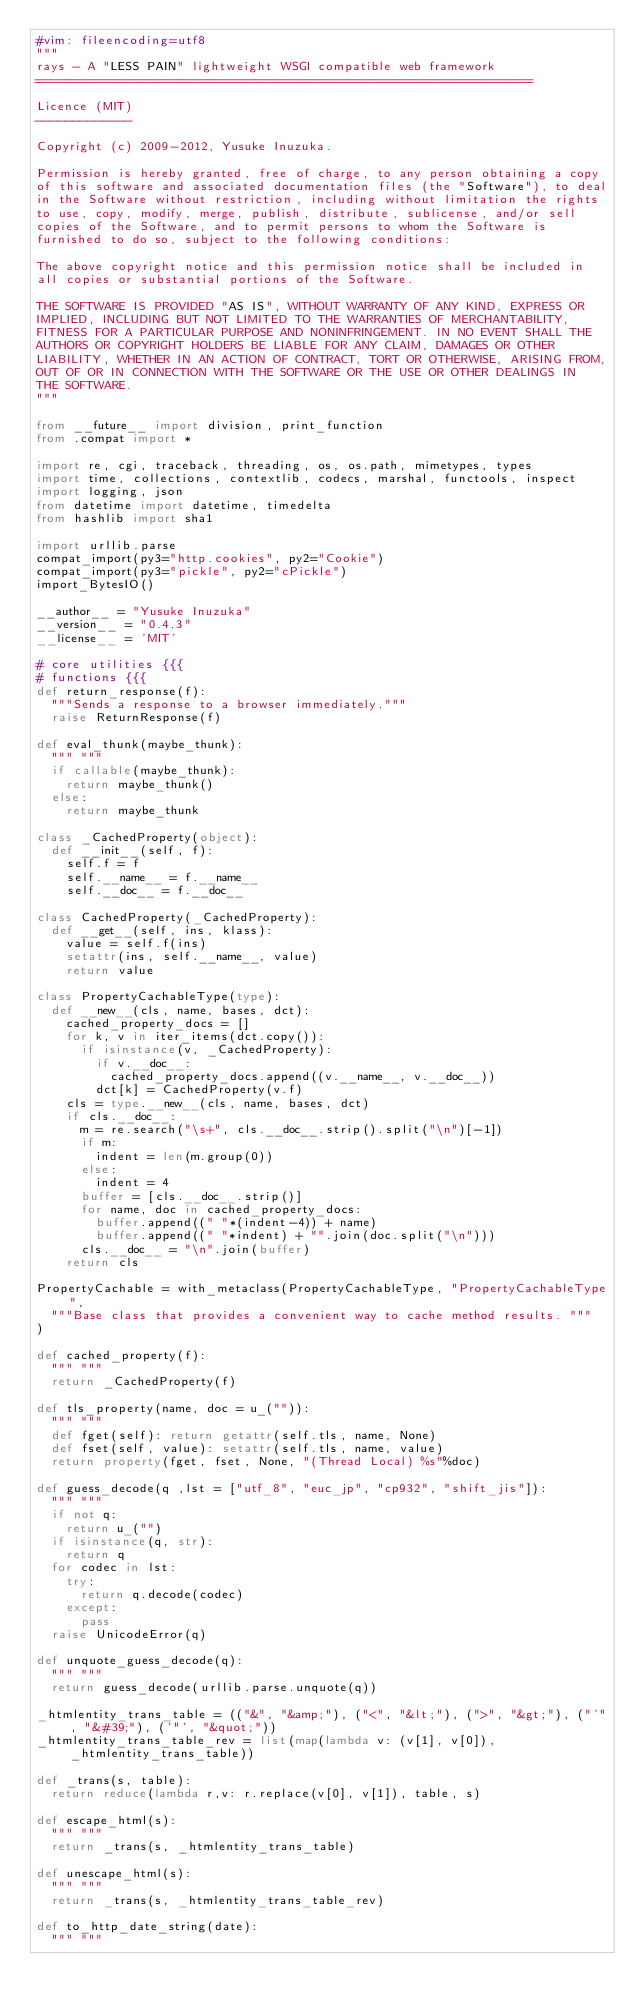<code> <loc_0><loc_0><loc_500><loc_500><_Python_>#vim: fileencoding=utf8
"""
rays - A "LESS PAIN" lightweight WSGI compatible web framework
===================================================================

Licence (MIT)
-------------
 
Copyright (c) 2009-2012, Yusuke Inuzuka.
 
Permission is hereby granted, free of charge, to any person obtaining a copy
of this software and associated documentation files (the "Software"), to deal
in the Software without restriction, including without limitation the rights
to use, copy, modify, merge, publish, distribute, sublicense, and/or sell
copies of the Software, and to permit persons to whom the Software is
furnished to do so, subject to the following conditions:
 
The above copyright notice and this permission notice shall be included in
all copies or substantial portions of the Software.
 
THE SOFTWARE IS PROVIDED "AS IS", WITHOUT WARRANTY OF ANY KIND, EXPRESS OR
IMPLIED, INCLUDING BUT NOT LIMITED TO THE WARRANTIES OF MERCHANTABILITY,
FITNESS FOR A PARTICULAR PURPOSE AND NONINFRINGEMENT. IN NO EVENT SHALL THE
AUTHORS OR COPYRIGHT HOLDERS BE LIABLE FOR ANY CLAIM, DAMAGES OR OTHER
LIABILITY, WHETHER IN AN ACTION OF CONTRACT, TORT OR OTHERWISE, ARISING FROM,
OUT OF OR IN CONNECTION WITH THE SOFTWARE OR THE USE OR OTHER DEALINGS IN
THE SOFTWARE.
"""

from __future__ import division, print_function
from .compat import *

import re, cgi, traceback, threading, os, os.path, mimetypes, types
import time, collections, contextlib, codecs, marshal, functools, inspect
import logging, json
from datetime import datetime, timedelta
from hashlib import sha1

import urllib.parse
compat_import(py3="http.cookies", py2="Cookie")
compat_import(py3="pickle", py2="cPickle")
import_BytesIO()

__author__ = "Yusuke Inuzuka"
__version__ = "0.4.3"
__license__ = 'MIT'

# core utilities {{{
# functions {{{
def return_response(f):
  """Sends a response to a browser immediately."""
  raise ReturnResponse(f)

def eval_thunk(maybe_thunk):
  """ """
  if callable(maybe_thunk):
    return maybe_thunk()
  else:
    return maybe_thunk 

class _CachedProperty(object):
  def __init__(self, f):
    self.f = f
    self.__name__ = f.__name__
    self.__doc__ = f.__doc__

class CachedProperty(_CachedProperty):
  def __get__(self, ins, klass):
    value = self.f(ins)
    setattr(ins, self.__name__, value)
    return value

class PropertyCachableType(type):
  def __new__(cls, name, bases, dct):
    cached_property_docs = []
    for k, v in iter_items(dct.copy()):
      if isinstance(v, _CachedProperty):
        if v.__doc__:
          cached_property_docs.append((v.__name__, v.__doc__))
        dct[k] = CachedProperty(v.f)
    cls = type.__new__(cls, name, bases, dct)
    if cls.__doc__:
      m = re.search("\s+", cls.__doc__.strip().split("\n")[-1])
      if m:
        indent = len(m.group(0))
      else:
        indent = 4
      buffer = [cls.__doc__.strip()]
      for name, doc in cached_property_docs:
        buffer.append((" "*(indent-4)) + name)
        buffer.append((" "*indent) + "".join(doc.split("\n")))
      cls.__doc__ = "\n".join(buffer)
    return cls

PropertyCachable = with_metaclass(PropertyCachableType, "PropertyCachableType", 
  """Base class that provides a convenient way to cache method results. """
)

def cached_property(f):
  """ """
  return _CachedProperty(f)

def tls_property(name, doc = u_("")):
  """ """
  def fget(self): return getattr(self.tls, name, None)
  def fset(self, value): setattr(self.tls, name, value)
  return property(fget, fset, None, "(Thread Local) %s"%doc)

def guess_decode(q ,lst = ["utf_8", "euc_jp", "cp932", "shift_jis"]):
  """ """
  if not q:
    return u_("")
  if isinstance(q, str):
    return q
  for codec in lst:
    try:
      return q.decode(codec)
    except:
      pass
  raise UnicodeError(q)

def unquote_guess_decode(q):
  """ """
  return guess_decode(urllib.parse.unquote(q))

_htmlentity_trans_table = (("&", "&amp;"), ("<", "&lt;"), (">", "&gt;"), ("'", "&#39;"), ('"', "&quot;"))
_htmlentity_trans_table_rev = list(map(lambda v: (v[1], v[0]), _htmlentity_trans_table))

def _trans(s, table):
  return reduce(lambda r,v: r.replace(v[0], v[1]), table, s)

def escape_html(s):
  """ """
  return _trans(s, _htmlentity_trans_table)

def unescape_html(s): 
  """ """
  return _trans(s, _htmlentity_trans_table_rev)

def to_http_date_string(date): 
  """ """</code> 